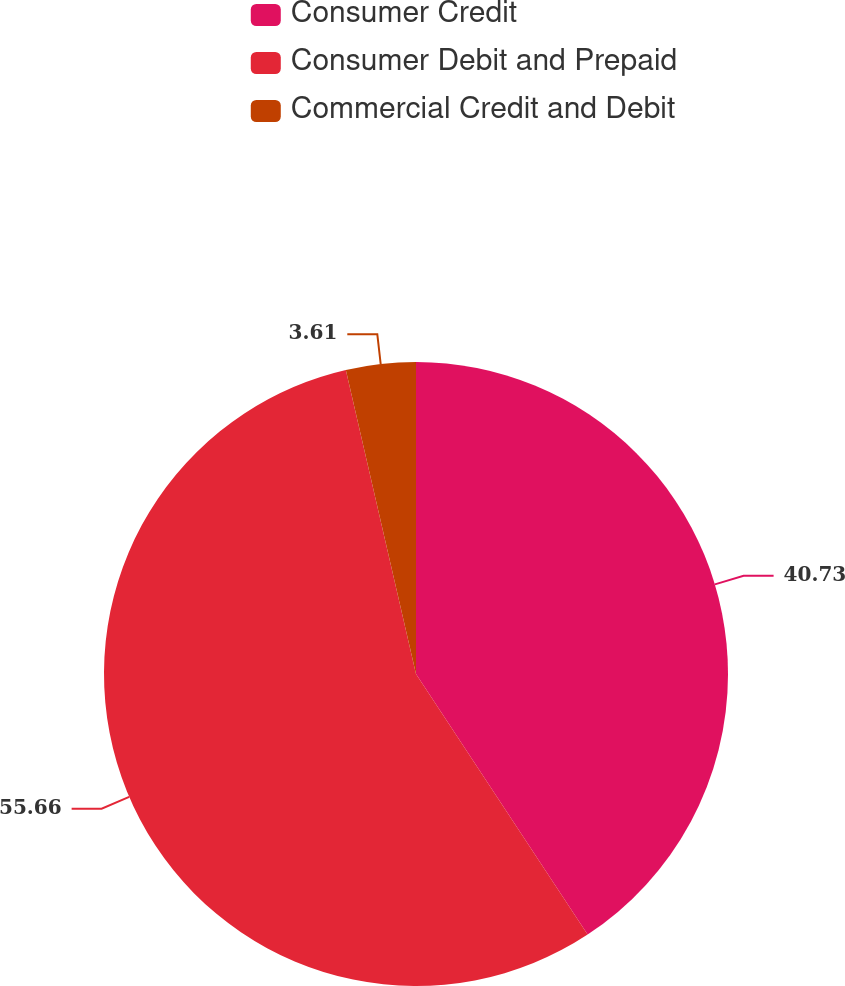Convert chart to OTSL. <chart><loc_0><loc_0><loc_500><loc_500><pie_chart><fcel>Consumer Credit<fcel>Consumer Debit and Prepaid<fcel>Commercial Credit and Debit<nl><fcel>40.73%<fcel>55.66%<fcel>3.61%<nl></chart> 